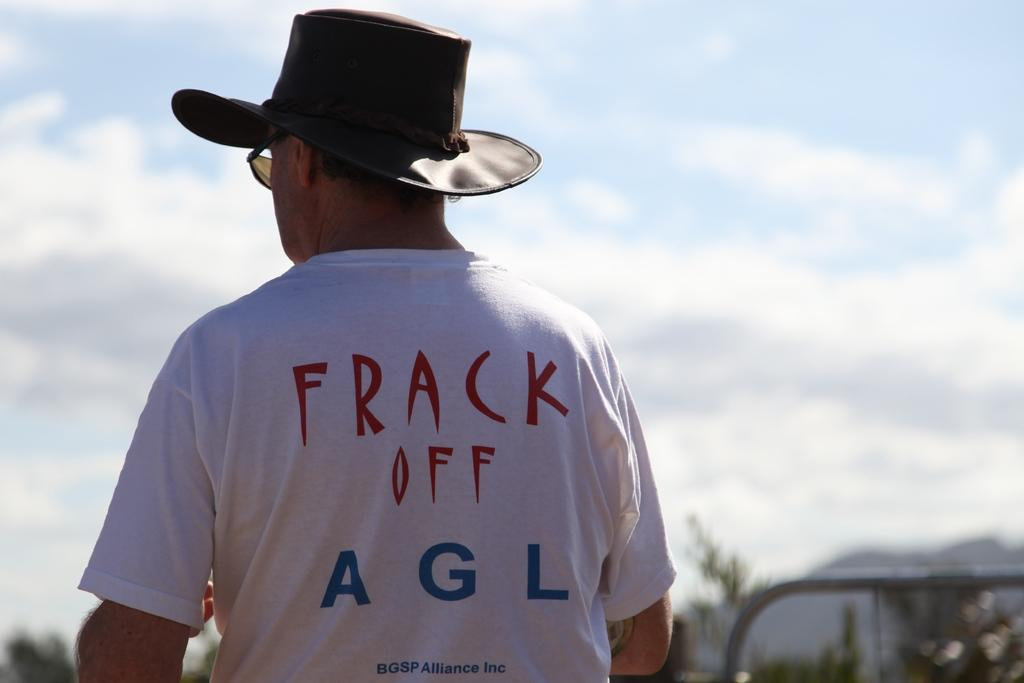<image>
Present a compact description of the photo's key features. A man wearing a cowboy hat and a white tee with a saying "Frack off" is shown from the behind. 